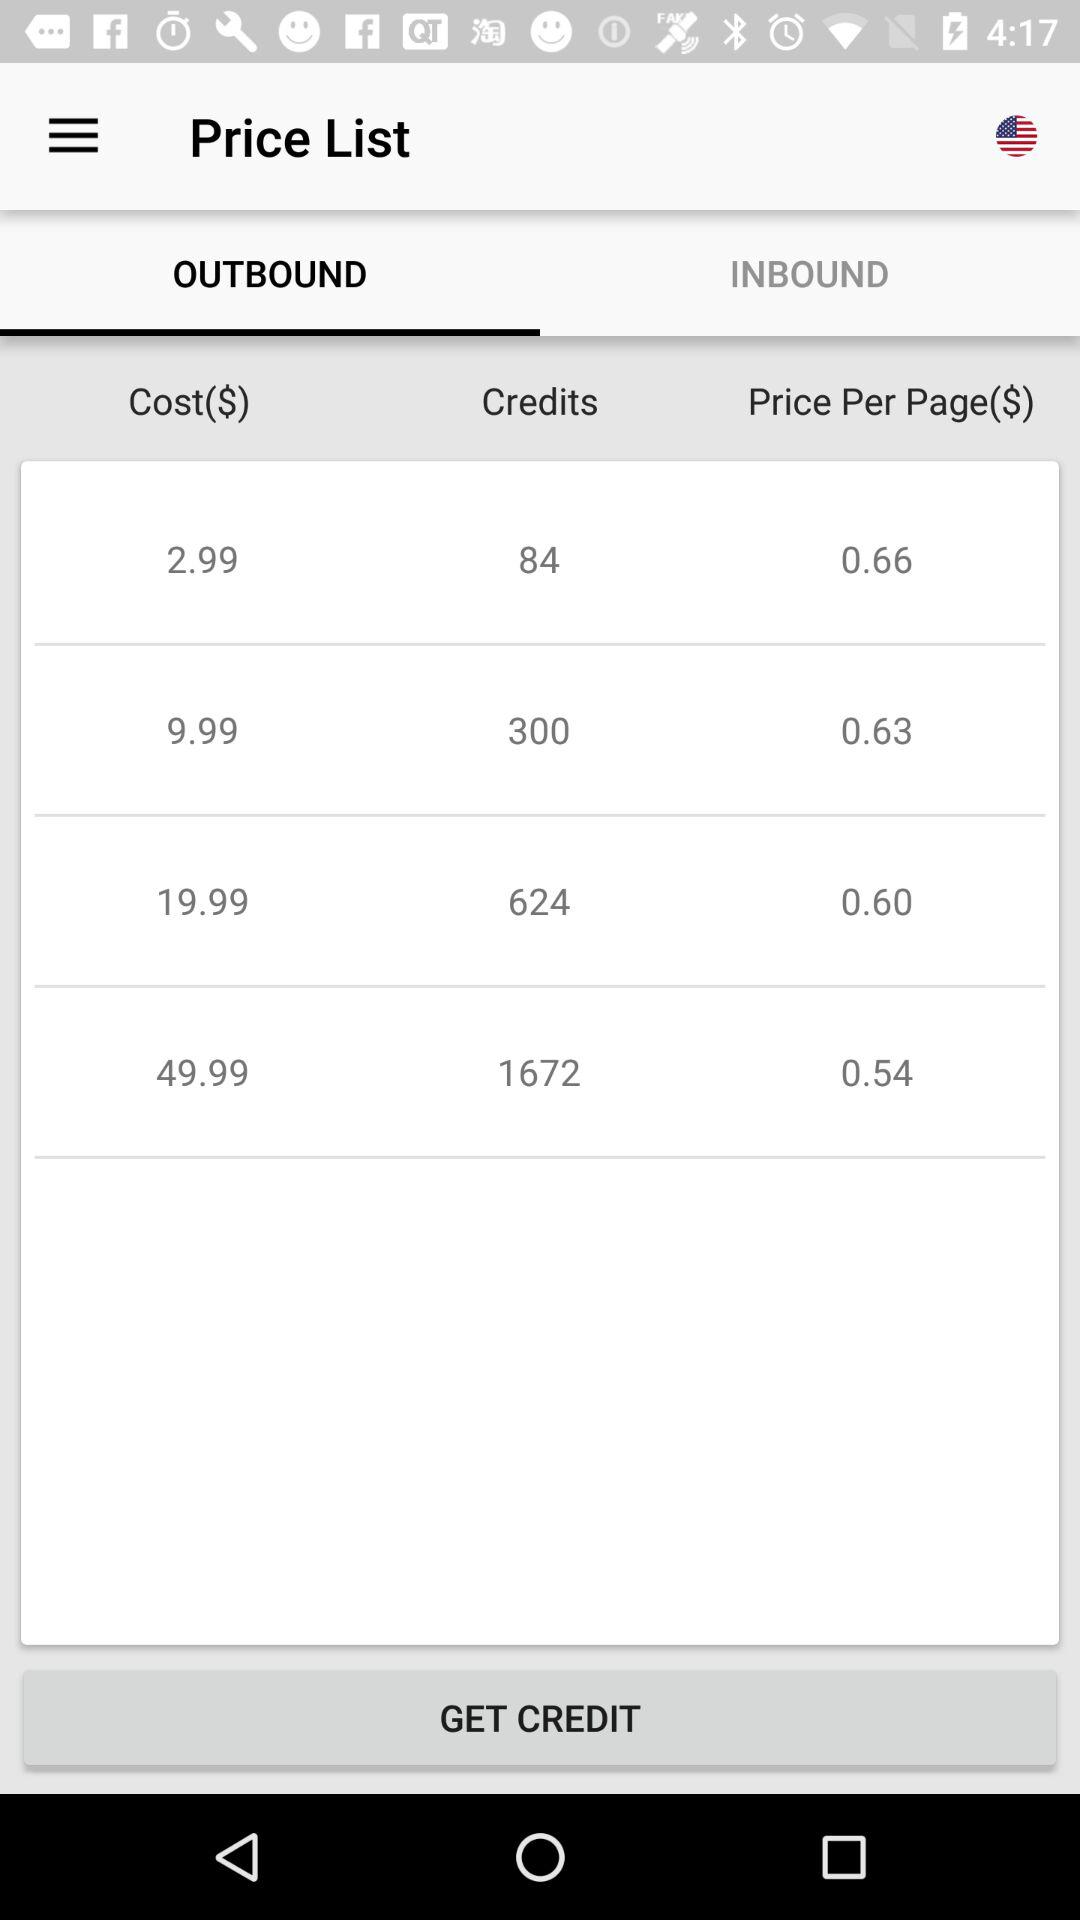Which is the "Price Per Page($)" of 1672 credits? The "Price Per Page($)" of 1672 credits is 0.54. 